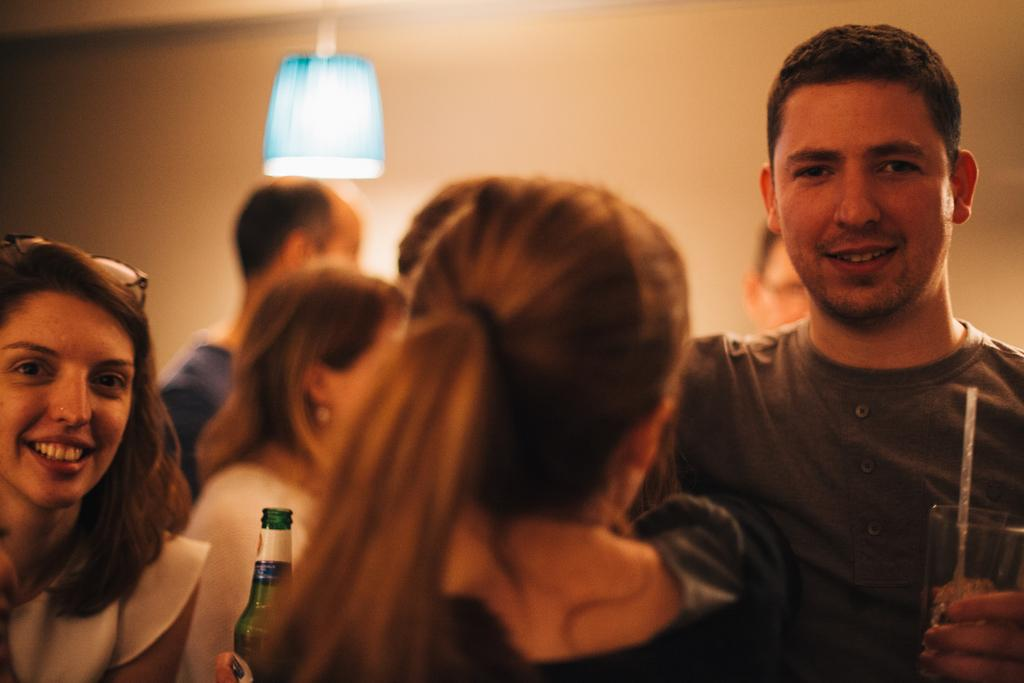What type of structure can be seen in the image? There is a wall in the image. What object provides light in the image? There is a lamp in the image. Are there any living beings present in the image? Yes, there are people present in the image. What type of container is visible in the image? There is a bottle in the image. What type of boot is being worn by the mom in the image? There is no mom or boot present in the image. What material is the plastic used for in the image? There is no plastic present in the image. 